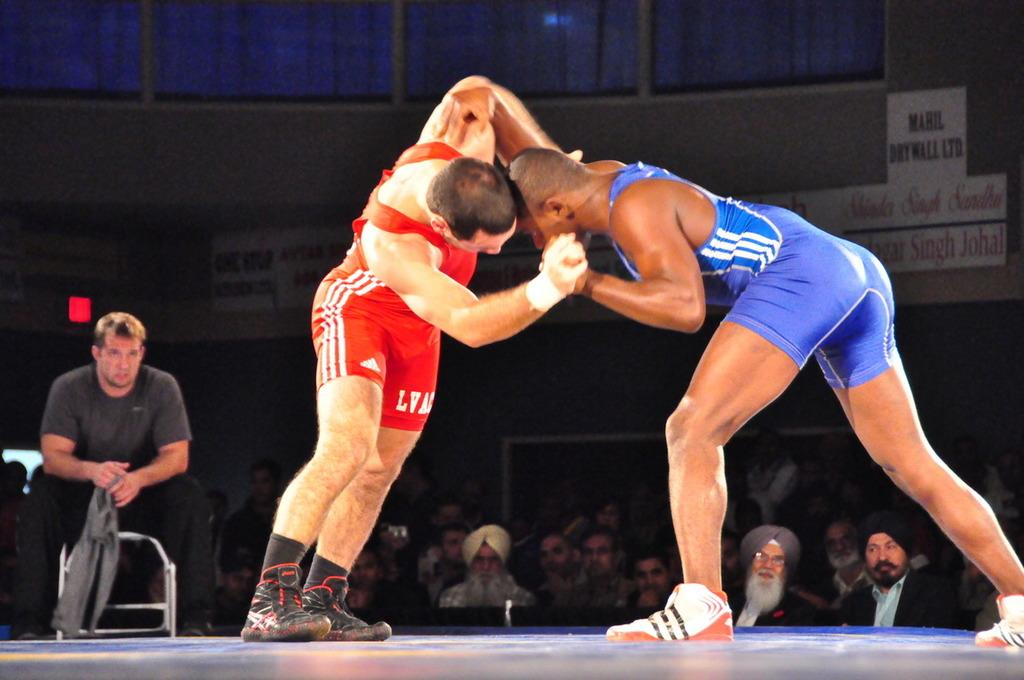<image>
Provide a brief description of the given image. Singh Johal is written on a banner seen behind the wrestlers. 